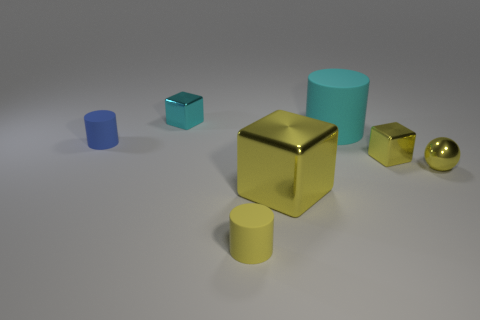There is a cylinder that is in front of the blue matte cylinder; what number of blue cylinders are on the left side of it? Upon closer examination of the image, there appears to be one blue cylinder positioned to the left side of the forefront blue matte cylinder. It's placed at a greater distance, closer to the corner of the scene. 